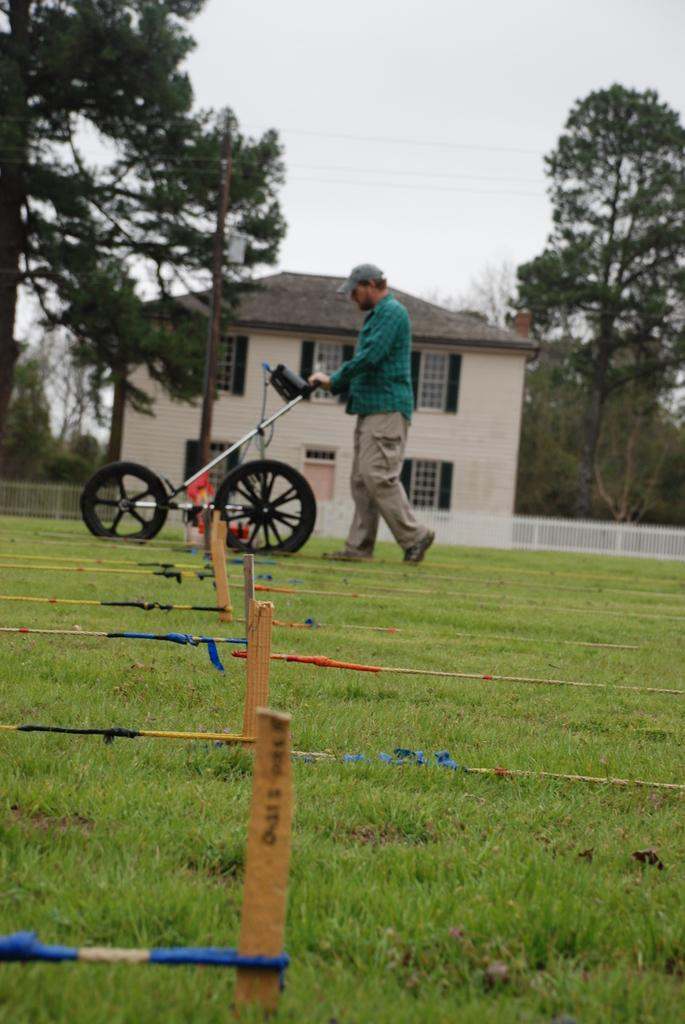What is the main object in the image? There is a cart in the image. What is the condition of the man in the image? The man is on the ground in the image. What type of surface is the man lying on? The ground is covered with grass. What structures can be seen in the background of the image? There is a house, a pole, and a fence in the background of the image. What else can be seen in the background of the image? There are trees and the sky visible in the background of the image. What type of engine is being repaired by the carpenter in the image? There is no engine or carpenter present in the image. How much dust can be seen on the cart in the image? There is no mention of dust in the image, so it cannot be determined how much dust is present. 